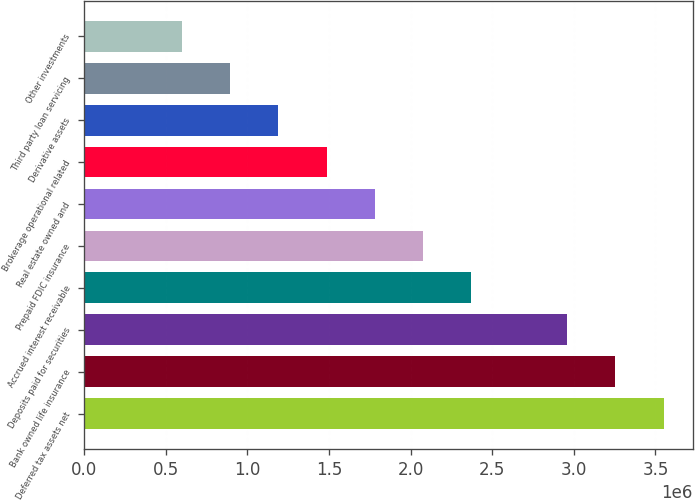<chart> <loc_0><loc_0><loc_500><loc_500><bar_chart><fcel>Deferred tax assets net<fcel>Bank owned life insurance<fcel>Deposits paid for securities<fcel>Accrued interest receivable<fcel>Prepaid FDIC insurance<fcel>Real estate owned and<fcel>Brokerage operational related<fcel>Derivative assets<fcel>Third party loan servicing<fcel>Other investments<nl><fcel>3.55046e+06<fcel>3.25557e+06<fcel>2.96067e+06<fcel>2.37088e+06<fcel>2.07598e+06<fcel>1.78109e+06<fcel>1.48619e+06<fcel>1.1913e+06<fcel>896401<fcel>601505<nl></chart> 